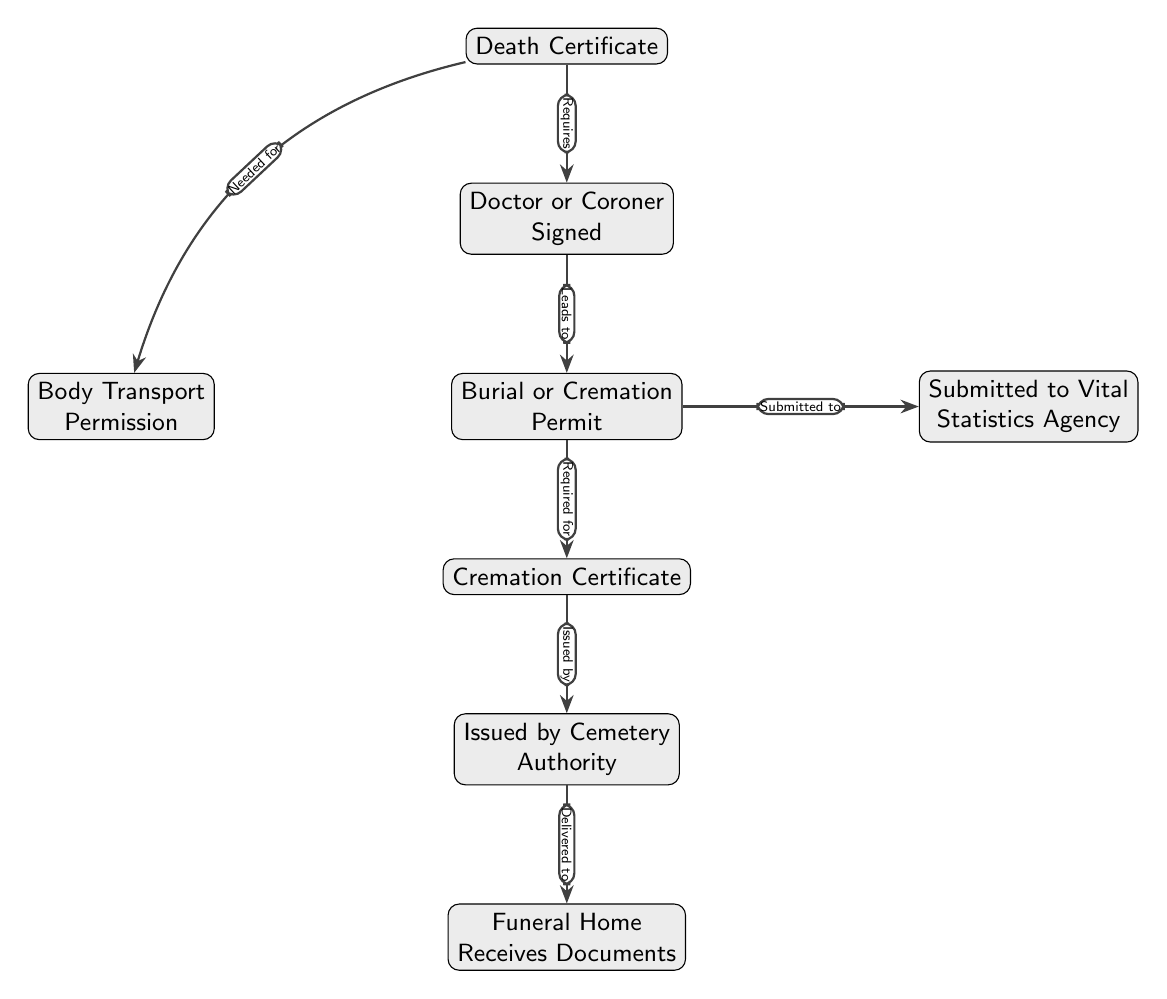What is the first document needed in the funeral process? The diagram shows that the first document required in the funeral process is the Death Certificate.
Answer: Death Certificate Who signs the Death Certificate? The diagram indicates that the Death Certificate must be signed by a Doctor or Coroner.
Answer: Doctor or Coroner How many major documents are shown in the diagram? Counting the nodes presented in the diagram, there are a total of seven major documents: Death Certificate, Doctor or Coroner Signed, Burial or Cremation Permit, Body Transport Permission, Cremation Certificate, Issued by Cemetery Authority, and Funeral Home Receives Documents.
Answer: 7 What does the Burial or Cremation Permit need to be submitted to? The diagram states that the Burial or Cremation Permit is submitted to the Vital Statistics Agency.
Answer: Vital Statistics Agency Which document is required for the Cremation Certificate? According to the diagram, the Burial or Cremation Permit is required for the Cremation Certificate.
Answer: Burial or Cremation Permit What document is needed for body transport? The diagram indicates that a Body Transport Permission is required, which is linked to the Death Certificate.
Answer: Body Transport Permission What delivers the final documents to the Funeral Home? The diagram shows that the Cemetery Authority issues documents that are then delivered to the Funeral Home.
Answer: Cemetery Authority List the sequence of documents starting from the Death Certificate to where they end up. Following the connections in the diagram, the sequence is: Death Certificate → Doctor or Coroner Signed → Burial or Cremation Permit → Submitted to Vital Statistics Agency → Cremation Certificate → Issued by Cemetery Authority → Funeral Home Receives Documents.
Answer: Death Certificate, Doctor or Coroner Signed, Burial or Cremation Permit, Submitted to Vital Statistics Agency, Cremation Certificate, Issued by Cemetery Authority, Funeral Home Receives Documents 